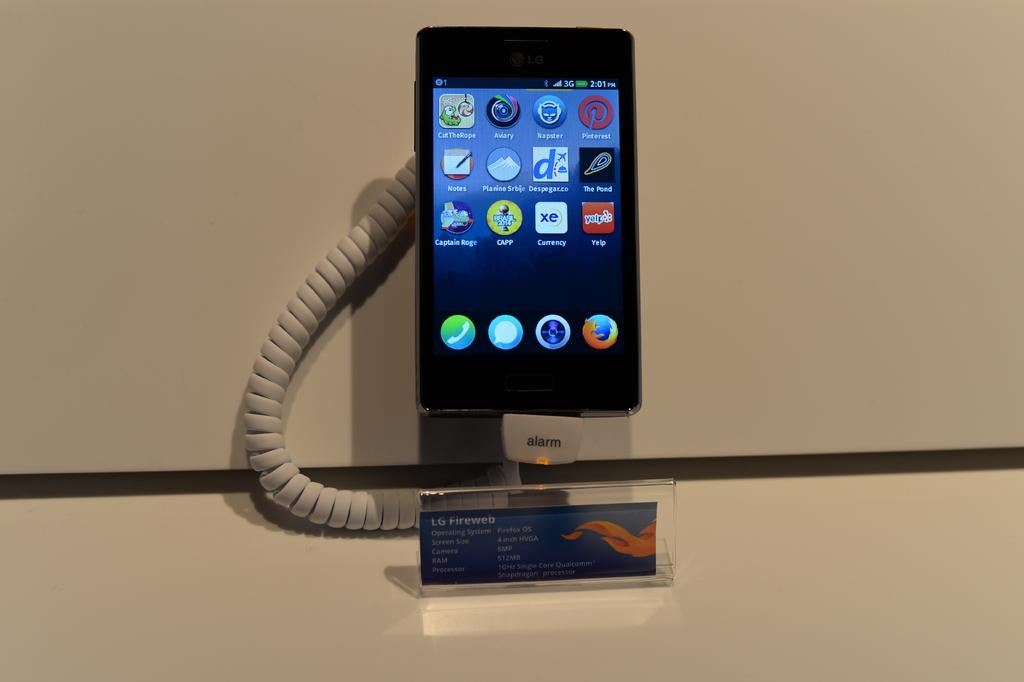What time is on the phone?
Ensure brevity in your answer.  Unanswerable. What is the top right app?
Your answer should be compact. Pinterest. 